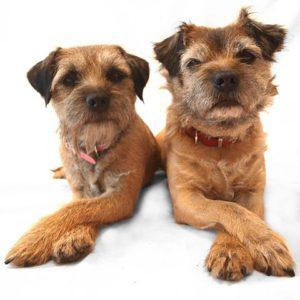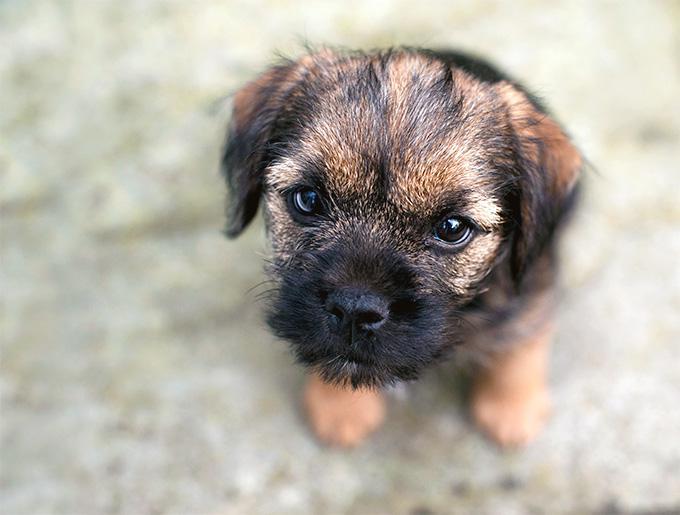The first image is the image on the left, the second image is the image on the right. Examine the images to the left and right. Is the description "A dog stands in profile on the grass with its tail extended." accurate? Answer yes or no. No. The first image is the image on the left, the second image is the image on the right. For the images displayed, is the sentence "The right image contains one dog that is standing on grass." factually correct? Answer yes or no. No. 